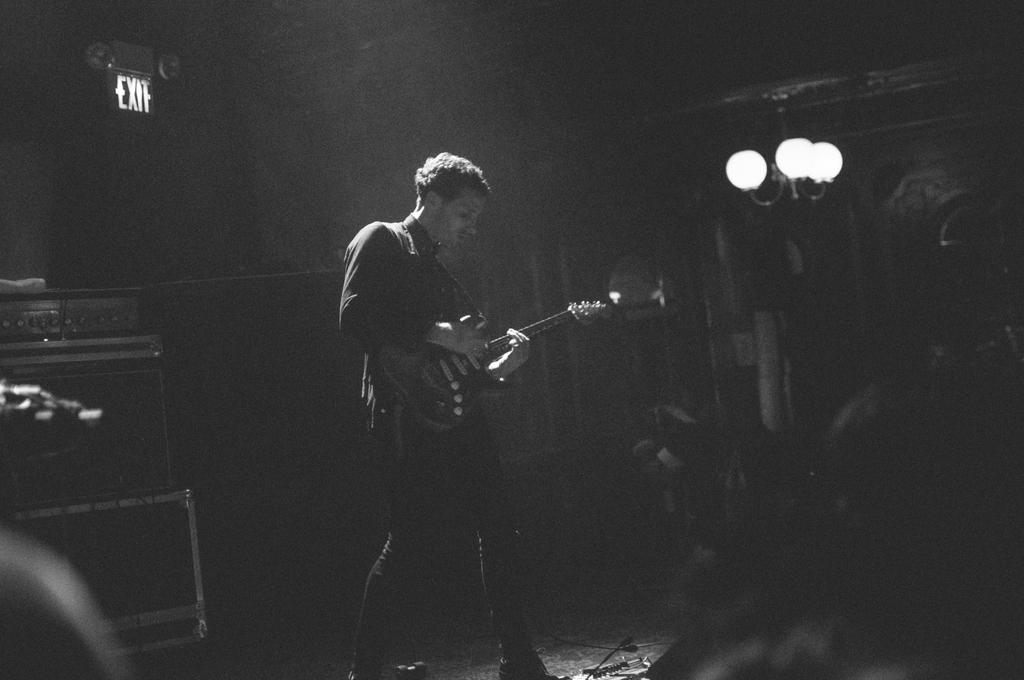Who is the person in the image? There is a man in the image. What is the man holding in the image? The man is holding a guitar. What can be seen in the background or surrounding the man? There are lights visible in the image. What is the title of the song the man is singing in the image? There is no indication in the image that the man is singing, nor is there any information about a song title. 